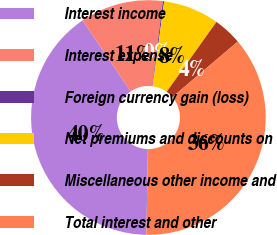<chart> <loc_0><loc_0><loc_500><loc_500><pie_chart><fcel>Interest income<fcel>Interest expense<fcel>Foreign currency gain (loss)<fcel>Net premiums and discounts on<fcel>Miscellaneous other income and<fcel>Total interest and other<nl><fcel>40.25%<fcel>11.45%<fcel>0.18%<fcel>7.69%<fcel>3.94%<fcel>36.49%<nl></chart> 